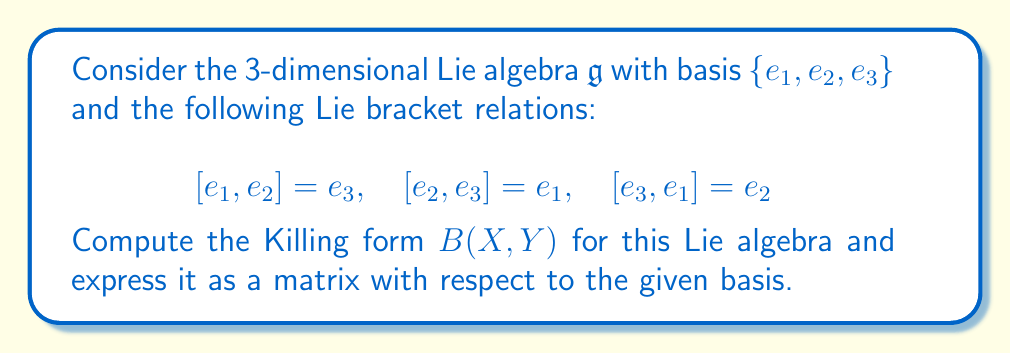Could you help me with this problem? To compute the Killing form for this Lie algebra, we'll follow these steps:

1) Recall that the Killing form is defined as $B(X,Y) = \text{tr}(\text{ad}_X \circ \text{ad}_Y)$, where $\text{ad}_X(Z) = [X,Z]$ is the adjoint representation.

2) First, we need to find the matrix representations of $\text{ad}_{e_1}$, $\text{ad}_{e_2}$, and $\text{ad}_{e_3}$ with respect to the given basis.

3) For $\text{ad}_{e_1}$:
   $\text{ad}_{e_1}(e_1) = 0$
   $\text{ad}_{e_1}(e_2) = e_3$
   $\text{ad}_{e_1}(e_3) = -e_2$
   
   So, $\text{ad}_{e_1} = \begin{pmatrix} 0 & 0 & 0 \\ 0 & 0 & -1 \\ 0 & 1 & 0 \end{pmatrix}$

4) Similarly, 
   $\text{ad}_{e_2} = \begin{pmatrix} 0 & 0 & 1 \\ 0 & 0 & 0 \\ -1 & 0 & 0 \end{pmatrix}$
   
   $\text{ad}_{e_3} = \begin{pmatrix} 0 & -1 & 0 \\ 1 & 0 & 0 \\ 0 & 0 & 0 \end{pmatrix}$

5) Now, we compute $B(e_i, e_j)$ for all $i,j \in \{1,2,3\}$:

   $B(e_1, e_1) = \text{tr}(\text{ad}_{e_1} \circ \text{ad}_{e_1}) = -2$
   $B(e_2, e_2) = \text{tr}(\text{ad}_{e_2} \circ \text{ad}_{e_2}) = -2$
   $B(e_3, e_3) = \text{tr}(\text{ad}_{e_3} \circ \text{ad}_{e_3}) = -2$
   
   $B(e_1, e_2) = B(e_2, e_1) = \text{tr}(\text{ad}_{e_1} \circ \text{ad}_{e_2}) = 0$
   $B(e_1, e_3) = B(e_3, e_1) = \text{tr}(\text{ad}_{e_1} \circ \text{ad}_{e_3}) = 0$
   $B(e_2, e_3) = B(e_3, e_2) = \text{tr}(\text{ad}_{e_2} \circ \text{ad}_{e_3}) = 0$

6) Therefore, the Killing form as a matrix with respect to the given basis is:

   $$B = \begin{pmatrix} -2 & 0 & 0 \\ 0 & -2 & 0 \\ 0 & 0 & -2 \end{pmatrix}$$
Answer: The Killing form for the given Lie algebra, expressed as a matrix with respect to the basis $\{e_1, e_2, e_3\}$, is:

$$B = \begin{pmatrix} -2 & 0 & 0 \\ 0 & -2 & 0 \\ 0 & 0 & -2 \end{pmatrix}$$ 